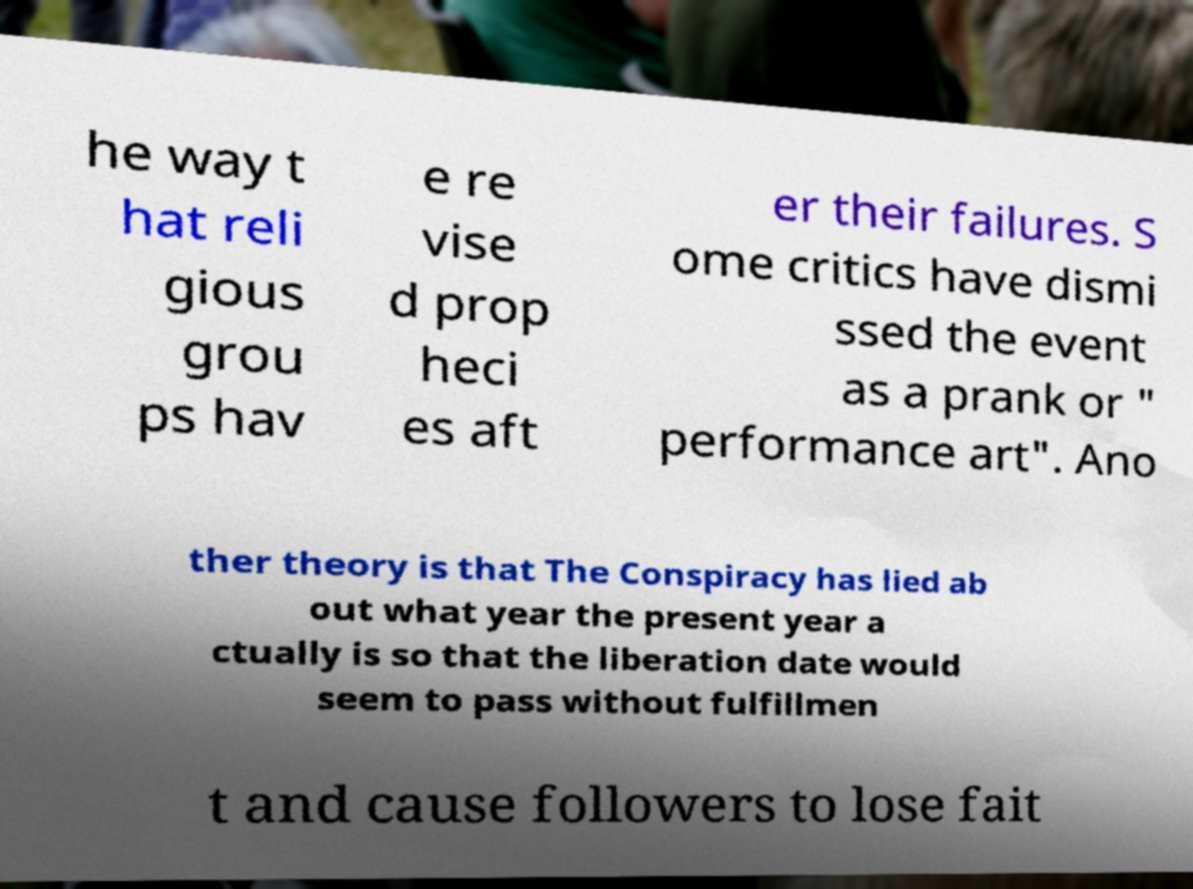For documentation purposes, I need the text within this image transcribed. Could you provide that? he way t hat reli gious grou ps hav e re vise d prop heci es aft er their failures. S ome critics have dismi ssed the event as a prank or " performance art". Ano ther theory is that The Conspiracy has lied ab out what year the present year a ctually is so that the liberation date would seem to pass without fulfillmen t and cause followers to lose fait 